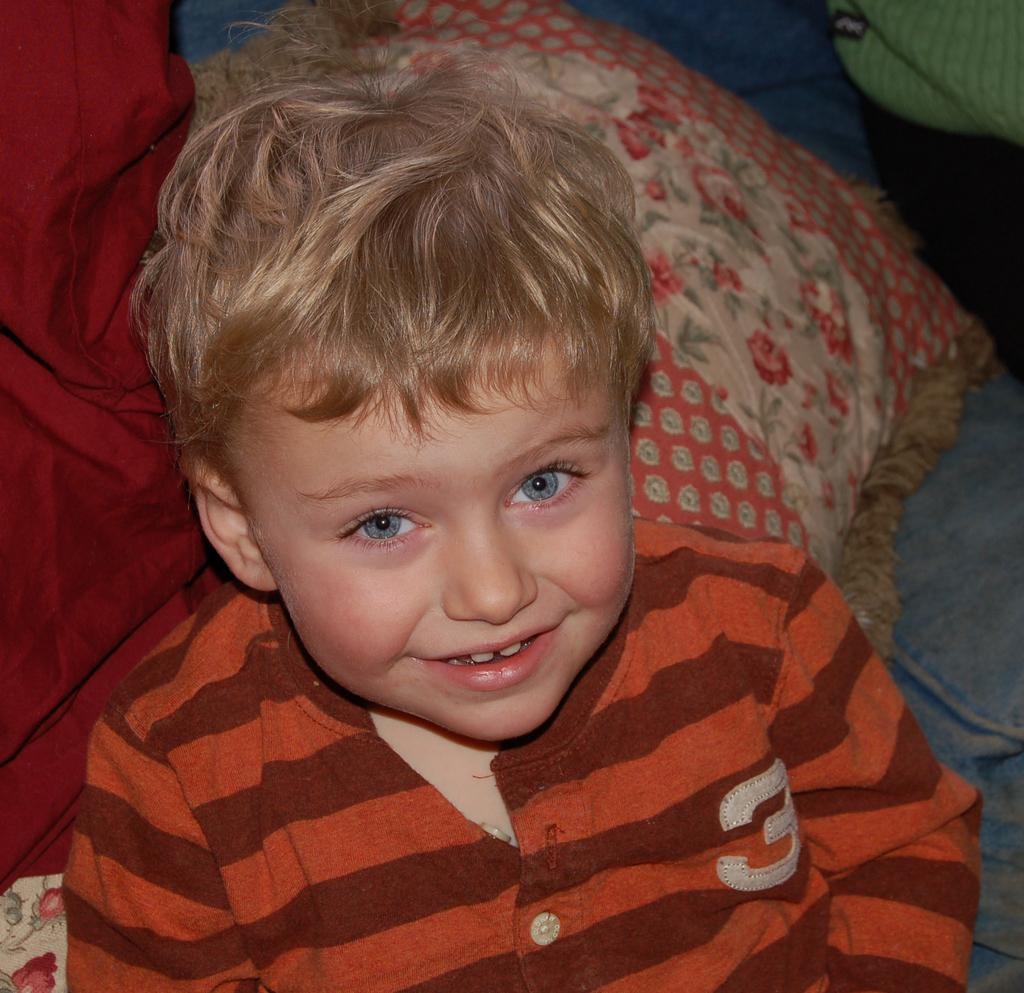Who is the main subject in the image? There is a boy in the middle of the image. What objects are present on either side of the boy? There is a pillow on the right side of the image and a blanket on the left side of the image. What grade is the boy in, based on the image? There is no information about the boy's grade in the image. --- 